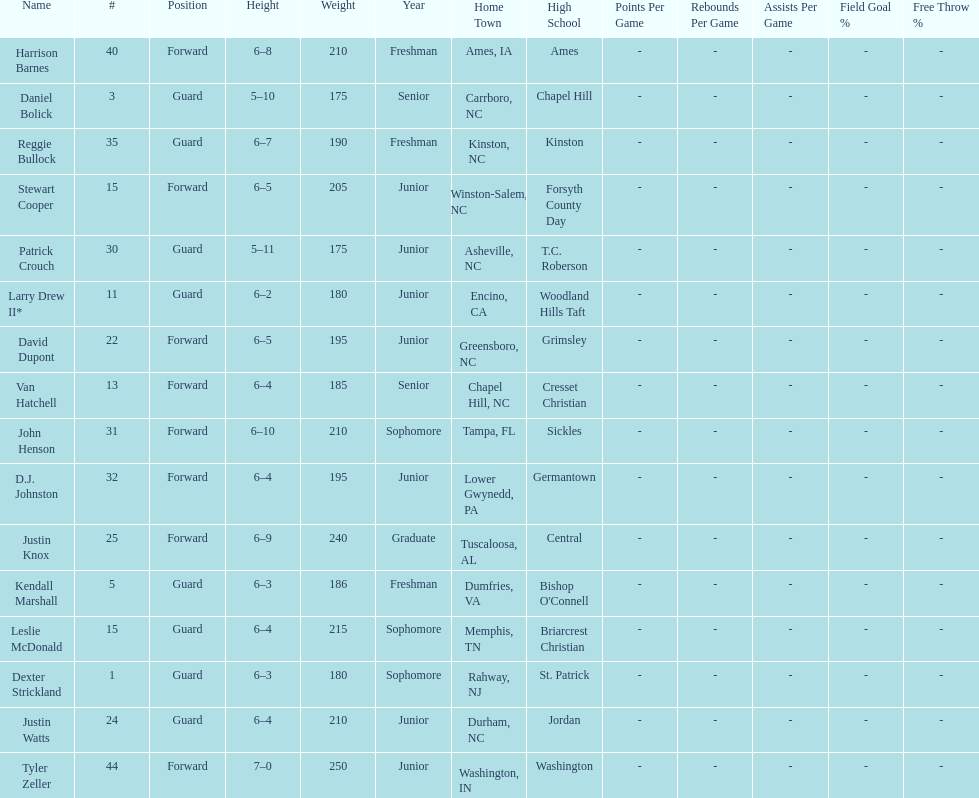What was the number of players with a height greater than van hatchell? 7. 